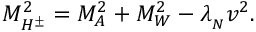<formula> <loc_0><loc_0><loc_500><loc_500>M _ { H ^ { \pm } } ^ { 2 } = M _ { A } ^ { 2 } + M _ { W } ^ { 2 } - \lambda _ { _ { N } } v ^ { 2 } .</formula> 